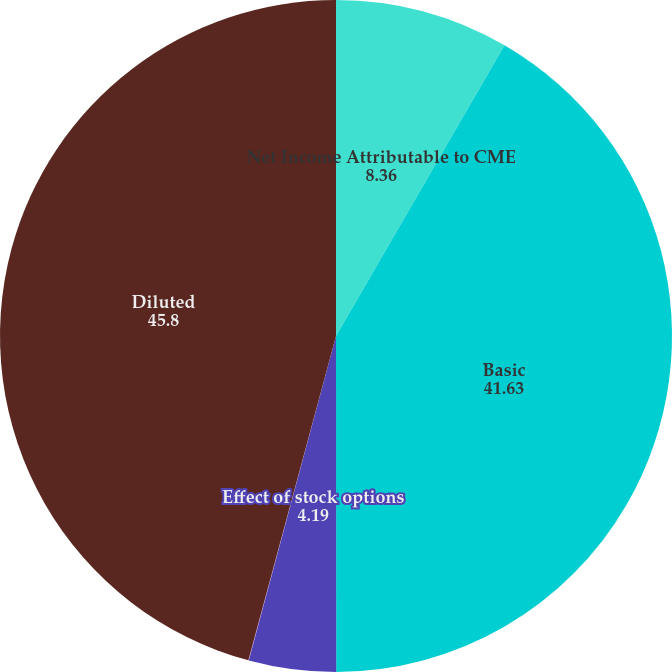<chart> <loc_0><loc_0><loc_500><loc_500><pie_chart><fcel>Net Income Attributable to CME<fcel>Basic<fcel>Effect of stock options<fcel>Effect of restricted stock<fcel>Diluted<nl><fcel>8.36%<fcel>41.63%<fcel>4.19%<fcel>0.02%<fcel>45.8%<nl></chart> 